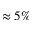Convert formula to latex. <formula><loc_0><loc_0><loc_500><loc_500>\approx 5 \%</formula> 